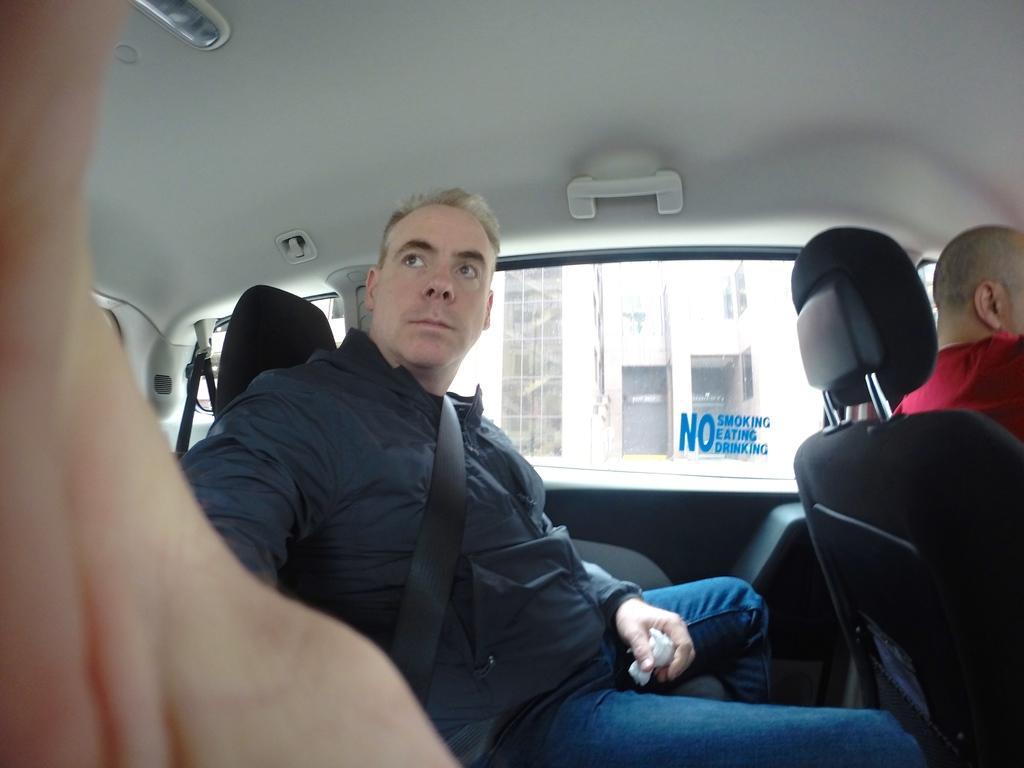Can you describe this image briefly? This is the picture of a man in black jacket sitting on a car. Behind the man there is a glass window through glass window we can see a building. 